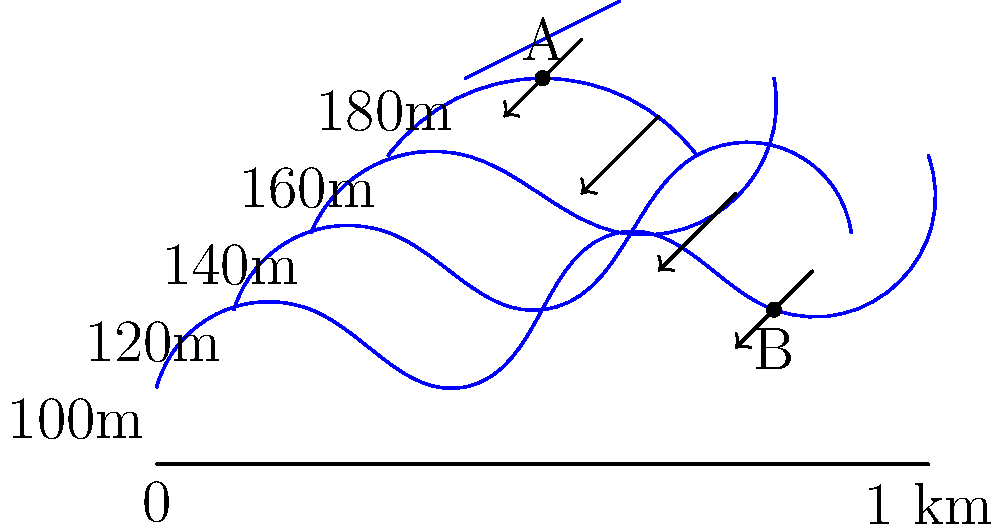Based on the topographic map provided, describe the most likely path of water flow from point A to point B, and explain how the elevation changes influence this flow pattern. To determine the water flow path from point A to point B and understand how elevation changes influence it, we need to follow these steps:

1. Identify the elevation at points A and B:
   - Point A is located near the 180m contour line
   - Point B is located near the 120m contour line

2. Recognize the general principle: Water flows from higher to lower elevations, following the path of steepest descent.

3. Trace the path of steepest descent:
   - From point A, water will flow perpendicular to the contour lines, moving towards lower elevations.
   - The flow will follow a southeastern direction initially, as indicated by the first arrow on the map.

4. Observe the impact of elevation changes:
   - The contour lines are closer together in some areas, indicating steeper slopes where water will flow faster.
   - In areas where contour lines are farther apart, the slope is gentler, and water flow may slow down.

5. Follow the arrows on the map:
   - The arrows indicate the general direction of water flow, which is consistent with the principle of flowing from higher to lower elevations.
   - The path curves slightly as it descends, following the topography of the land.

6. Reach point B:
   - The water flow continues in a generally southern direction until it reaches point B at a lower elevation.

The elevation changes influence the flow pattern by:
   a) Determining the direction of flow (always towards lower elevations)
   b) Affecting the speed of flow (faster on steeper slopes, slower on gentler slopes)
   c) Shaping the path of the water (curving around higher elevations and following valleys or depressions)
Answer: Water flows southeast from A to B, following the steepest descent path influenced by elevation changes. 